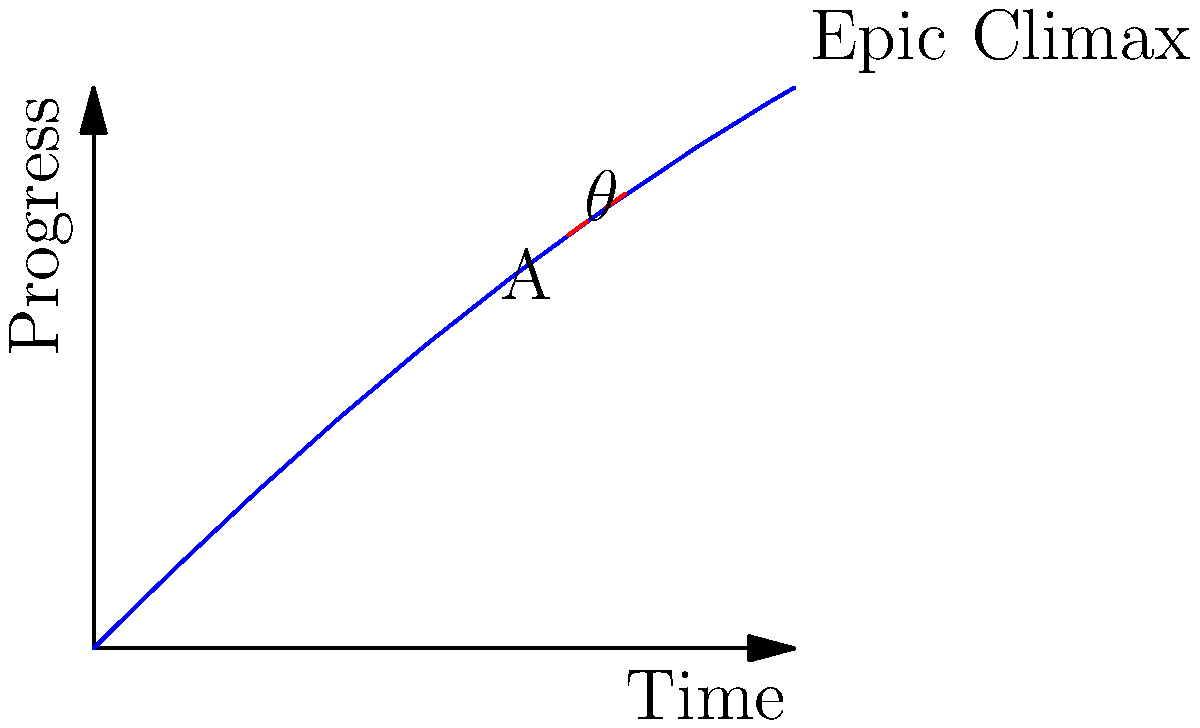In the grand theater of software development, our project's trajectory soars towards its epic climax! At point A, the tangent line forms an angle $\theta$ with the horizontal axis. If the slope of this line is $\frac{3}{4}$, what is the value of $\tan \theta$? Express your answer as a dramatic declaration of our project's ascent! Let us embark on this mathematical journey with the fervor of a thousand developers!

1) In the realm of trigonometry, the slope of a line is equivalent to the tangent of the angle it forms with the horizontal axis.

2) We are given that the slope of the tangent line at point A is $\frac{3}{4}$.

3) By definition, $\tan \theta = \frac{\text{opposite}}{\text{adjacent}} = \frac{\text{rise}}{\text{run}}$

4) The slope of a line is also defined as $\frac{\text{rise}}{\text{run}}$

5) Therefore, we can conclude that:

   $\tan \theta = \text{slope} = \frac{3}{4}$

6) Lo and behold! The answer reveals itself in a moment of pure dramatic tension!
Answer: $\tan \theta = \frac{3}{4}$ 